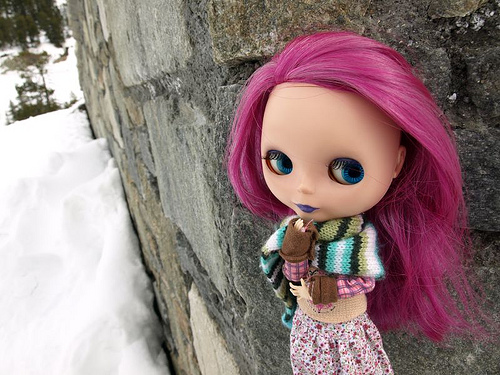<image>
Is the doll to the right of the wall? Yes. From this viewpoint, the doll is positioned to the right side relative to the wall. 